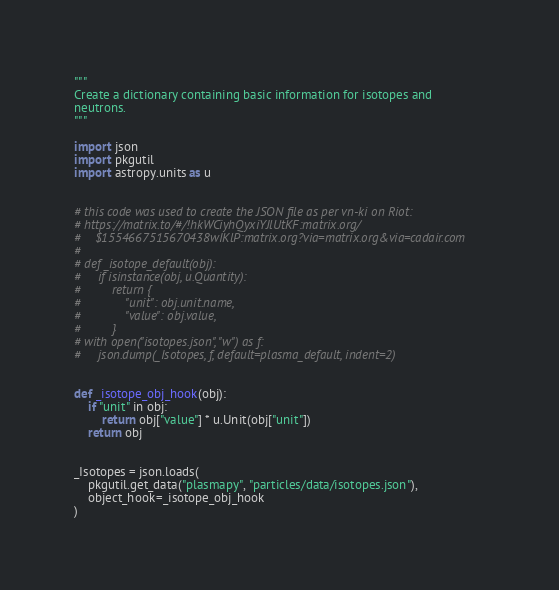<code> <loc_0><loc_0><loc_500><loc_500><_Python_>"""
Create a dictionary containing basic information for isotopes and
neutrons.
"""

import json
import pkgutil
import astropy.units as u


# this code was used to create the JSON file as per vn-ki on Riot:
# https://matrix.to/#/!hkWCiyhQyxiYJlUtKF:matrix.org/
#    $1554667515670438wIKlP:matrix.org?via=matrix.org&via=cadair.com
#
# def _isotope_default(obj):
#     if isinstance(obj, u.Quantity):
#         return {
#             "unit": obj.unit.name,
#             "value": obj.value,
#         }
# with open("isotopes.json", "w") as f:
#     json.dump(_Isotopes, f, default=plasma_default, indent=2)


def _isotope_obj_hook(obj):
    if "unit" in obj:
        return obj["value"] * u.Unit(obj["unit"])
    return obj


_Isotopes = json.loads(
    pkgutil.get_data("plasmapy", "particles/data/isotopes.json"),
    object_hook=_isotope_obj_hook
)
</code> 